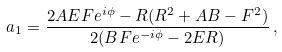<formula> <loc_0><loc_0><loc_500><loc_500>a _ { 1 } = \frac { 2 A E F e ^ { i \phi } - R ( R ^ { 2 } + A B - F ^ { 2 } ) } { 2 ( B F e ^ { - i \phi } - 2 E R ) } \, ,</formula> 